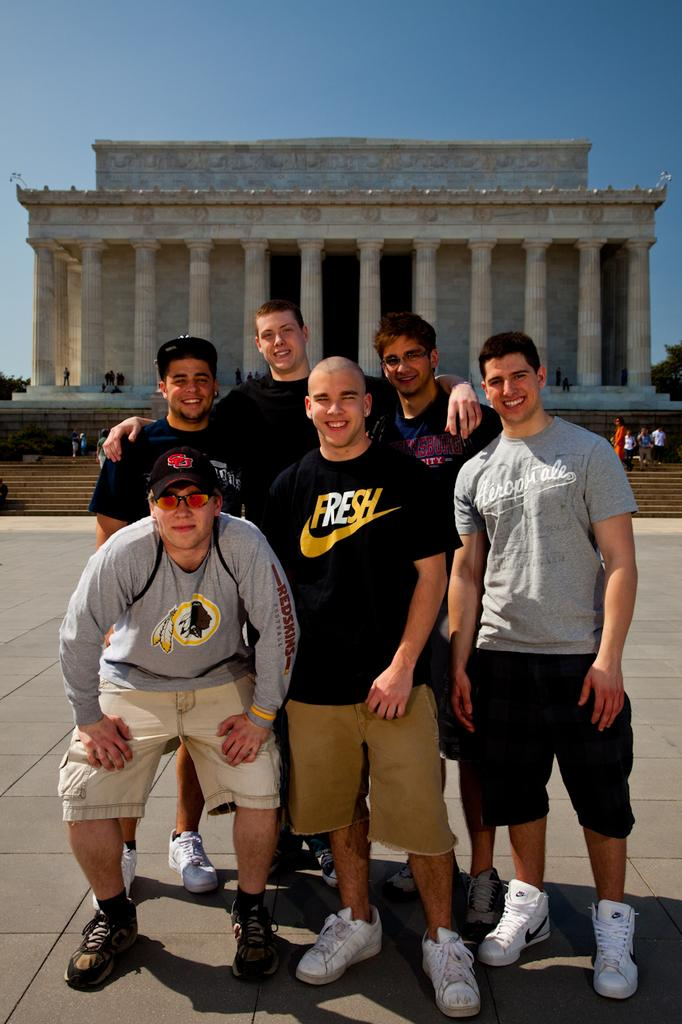<image>
Give a short and clear explanation of the subsequent image. The men are standing in front of a monument and the one in the middle has a t-shirt that says fresh. 